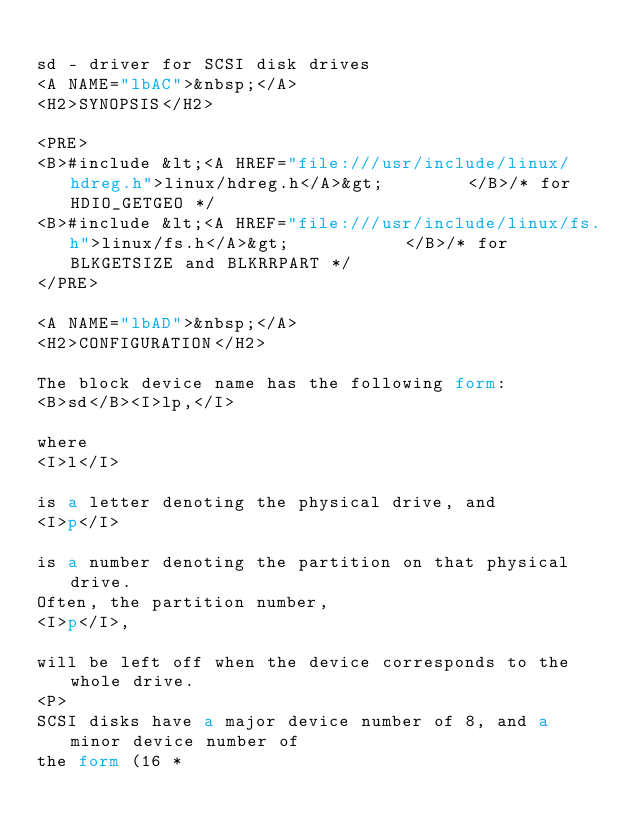<code> <loc_0><loc_0><loc_500><loc_500><_HTML_>
sd - driver for SCSI disk drives
<A NAME="lbAC">&nbsp;</A>
<H2>SYNOPSIS</H2>

<PRE>
<B>#include &lt;<A HREF="file:///usr/include/linux/hdreg.h">linux/hdreg.h</A>&gt;        </B>/* for HDIO_GETGEO */
<B>#include &lt;<A HREF="file:///usr/include/linux/fs.h">linux/fs.h</A>&gt;           </B>/* for BLKGETSIZE and BLKRRPART */
</PRE>

<A NAME="lbAD">&nbsp;</A>
<H2>CONFIGURATION</H2>

The block device name has the following form:
<B>sd</B><I>lp,</I>

where
<I>l</I>

is a letter denoting the physical drive, and
<I>p</I>

is a number denoting the partition on that physical drive.
Often, the partition number,
<I>p</I>,

will be left off when the device corresponds to the whole drive.
<P>
SCSI disks have a major device number of 8, and a minor device number of
the form (16 *</code> 